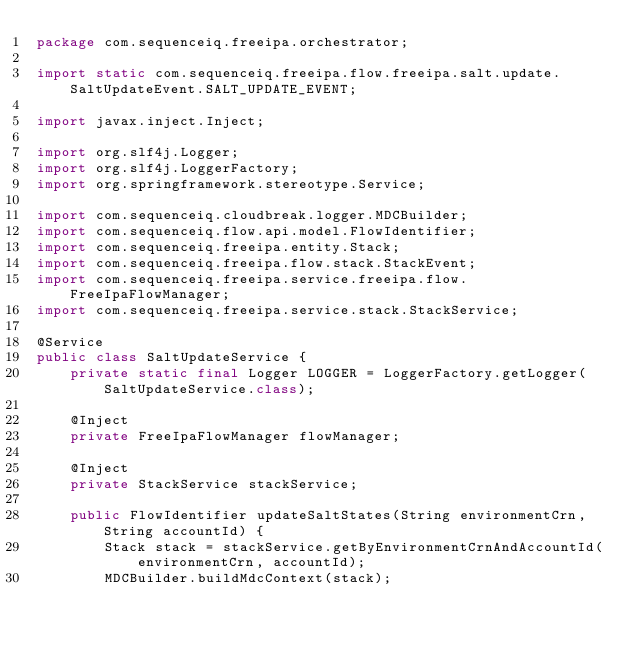<code> <loc_0><loc_0><loc_500><loc_500><_Java_>package com.sequenceiq.freeipa.orchestrator;

import static com.sequenceiq.freeipa.flow.freeipa.salt.update.SaltUpdateEvent.SALT_UPDATE_EVENT;

import javax.inject.Inject;

import org.slf4j.Logger;
import org.slf4j.LoggerFactory;
import org.springframework.stereotype.Service;

import com.sequenceiq.cloudbreak.logger.MDCBuilder;
import com.sequenceiq.flow.api.model.FlowIdentifier;
import com.sequenceiq.freeipa.entity.Stack;
import com.sequenceiq.freeipa.flow.stack.StackEvent;
import com.sequenceiq.freeipa.service.freeipa.flow.FreeIpaFlowManager;
import com.sequenceiq.freeipa.service.stack.StackService;

@Service
public class SaltUpdateService {
    private static final Logger LOGGER = LoggerFactory.getLogger(SaltUpdateService.class);

    @Inject
    private FreeIpaFlowManager flowManager;

    @Inject
    private StackService stackService;

    public FlowIdentifier updateSaltStates(String environmentCrn, String accountId) {
        Stack stack = stackService.getByEnvironmentCrnAndAccountId(environmentCrn, accountId);
        MDCBuilder.buildMdcContext(stack);</code> 